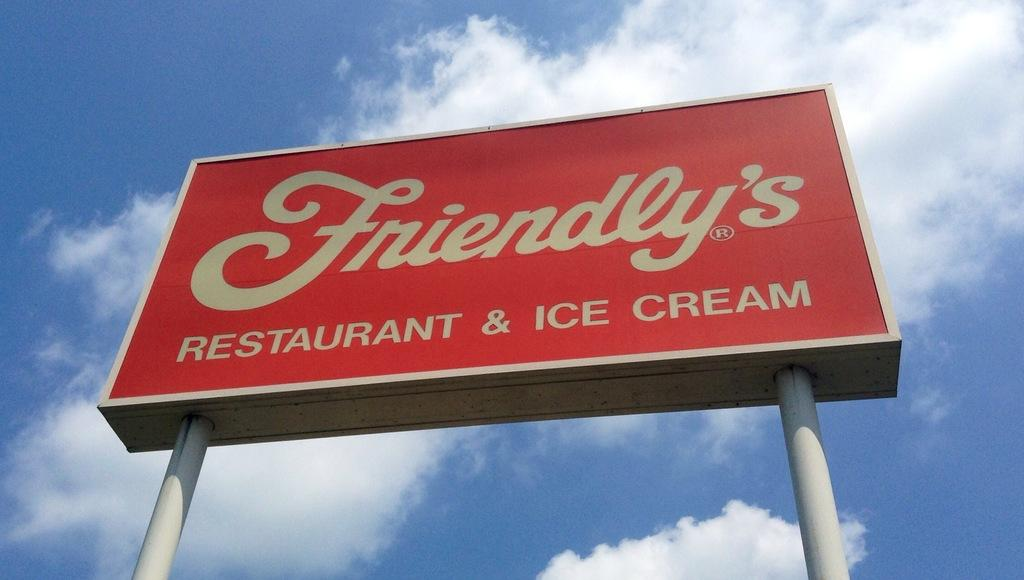<image>
Provide a brief description of the given image. The big red and white sign advertises Friendly's Restaurant and Ice Cream. 